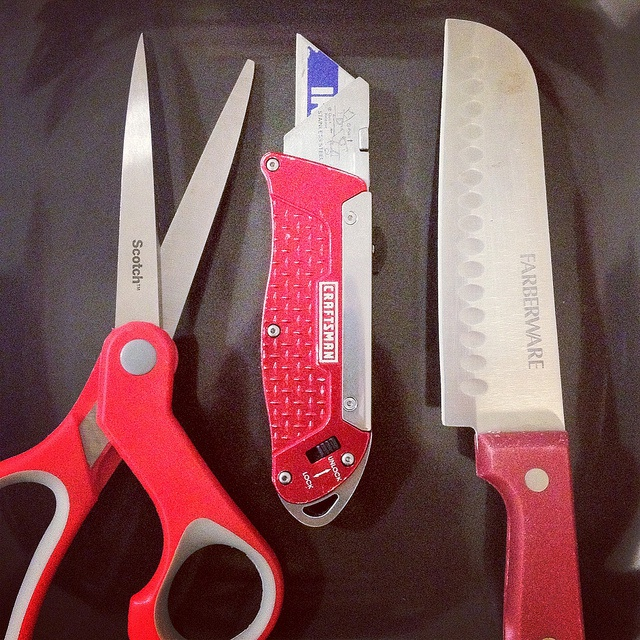Describe the objects in this image and their specific colors. I can see scissors in black, red, and lightgray tones, knife in black, lightgray, tan, and brown tones, and knife in black, lightgray, red, salmon, and brown tones in this image. 